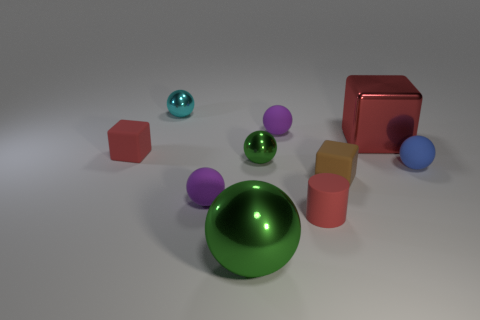How many gray things are either tiny objects or shiny cylinders?
Your answer should be compact. 0. There is a tiny object to the left of the tiny cyan metallic object; does it have the same color as the large shiny object behind the tiny red matte block?
Ensure brevity in your answer.  Yes. What is the color of the matte block right of the cube on the left side of the tiny block right of the large green metallic thing?
Provide a short and direct response. Brown. Is there a red metal thing that is behind the large metal thing on the right side of the brown rubber object?
Your answer should be very brief. No. Does the big metal thing to the right of the large green ball have the same shape as the brown object?
Provide a short and direct response. Yes. Is there any other thing that is the same shape as the tiny blue rubber thing?
Keep it short and to the point. Yes. What number of spheres are either cyan things or small blue matte things?
Give a very brief answer. 2. How many green rubber cubes are there?
Ensure brevity in your answer.  0. There is a metallic thing that is in front of the tiny red thing that is to the right of the small green thing; what is its size?
Keep it short and to the point. Large. How many other things are the same size as the red cylinder?
Ensure brevity in your answer.  7. 